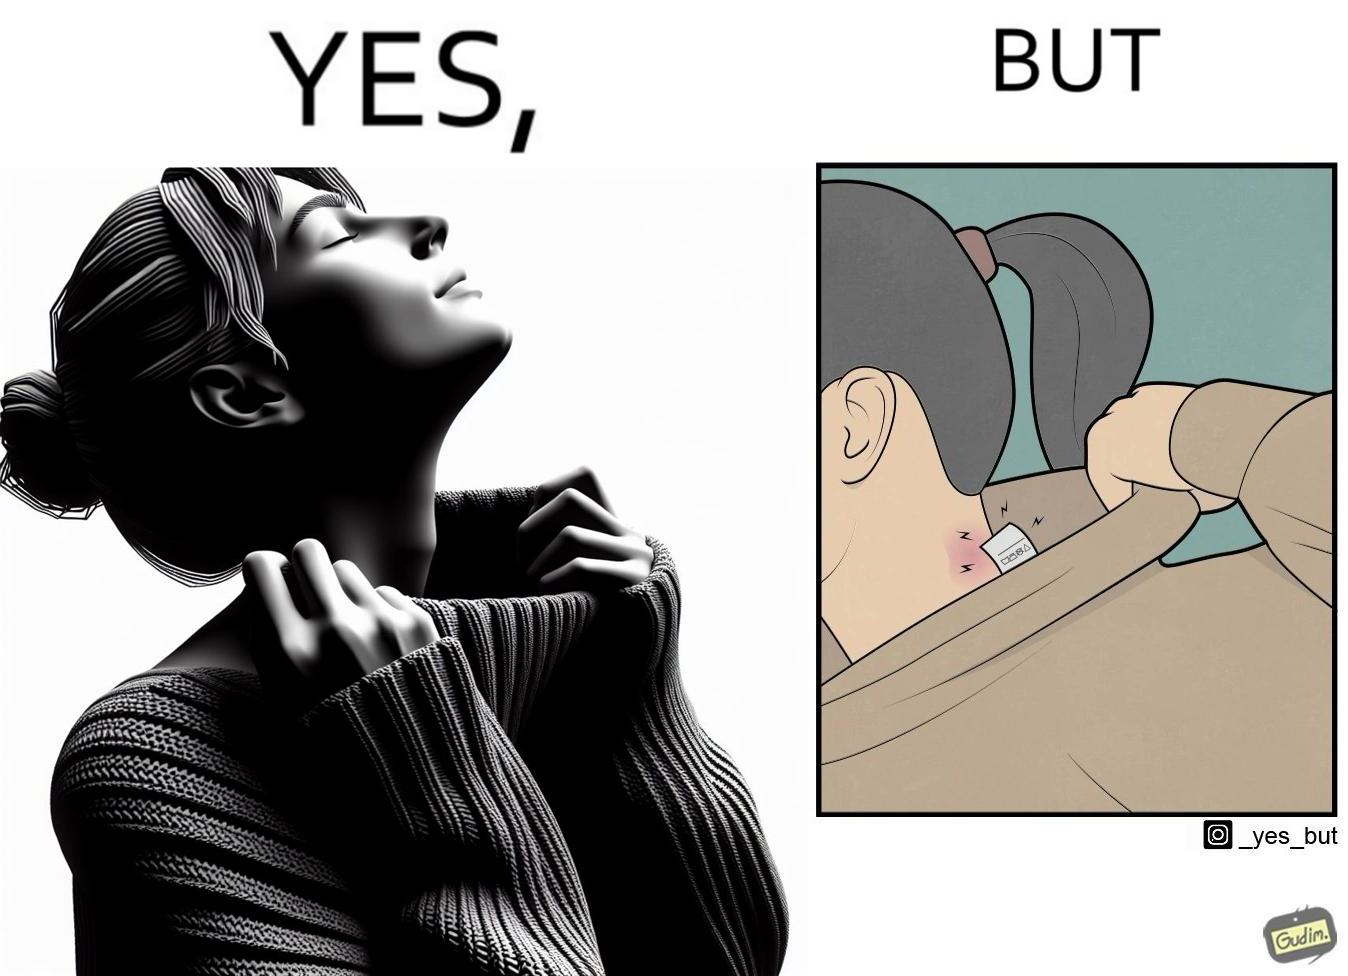What is the satirical meaning behind this image? The images are funny since it shows how even though sweaters and other clothings provide much comfort, a tiny manufacturers tag ends up causing the user a lot of discomfort due to constant scratching 